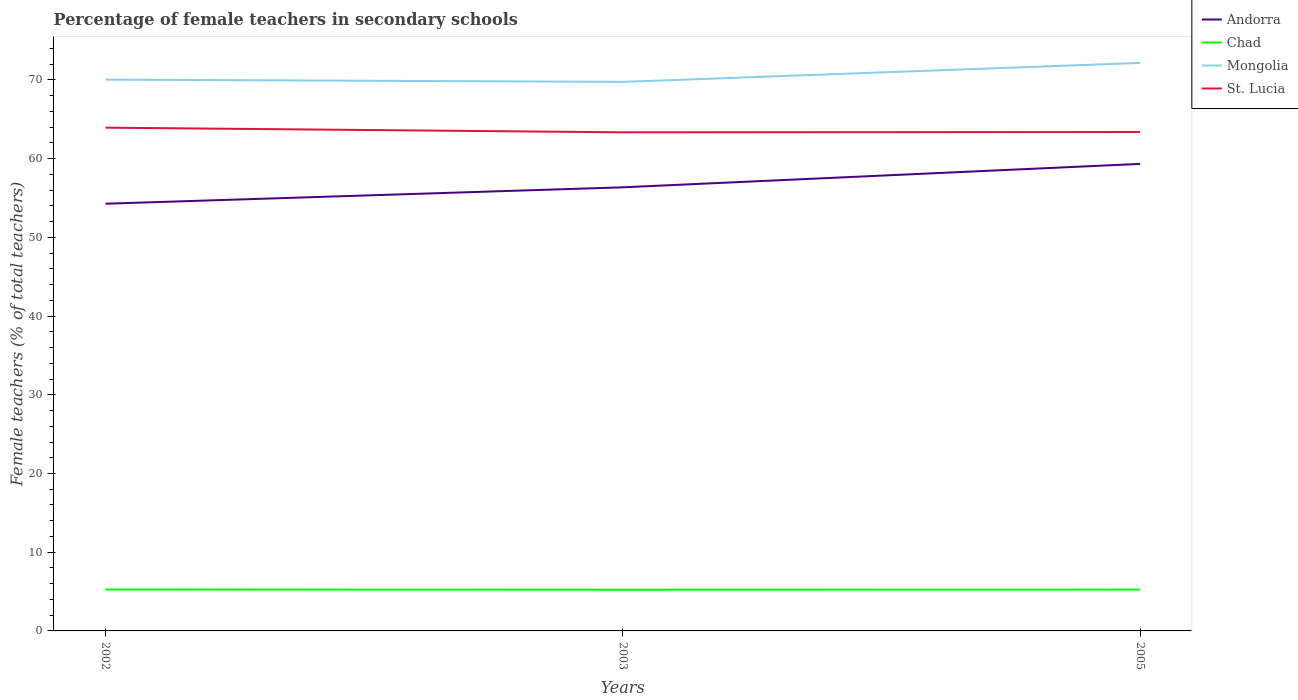How many different coloured lines are there?
Provide a short and direct response. 4. Is the number of lines equal to the number of legend labels?
Offer a very short reply. Yes. Across all years, what is the maximum percentage of female teachers in Chad?
Make the answer very short. 5.23. In which year was the percentage of female teachers in Andorra maximum?
Make the answer very short. 2002. What is the total percentage of female teachers in St. Lucia in the graph?
Provide a succinct answer. 0.56. What is the difference between the highest and the second highest percentage of female teachers in Andorra?
Your answer should be very brief. 5.06. How many lines are there?
Keep it short and to the point. 4. How many years are there in the graph?
Keep it short and to the point. 3. What is the difference between two consecutive major ticks on the Y-axis?
Provide a succinct answer. 10. Does the graph contain any zero values?
Give a very brief answer. No. Does the graph contain grids?
Your answer should be very brief. No. Where does the legend appear in the graph?
Your answer should be compact. Top right. What is the title of the graph?
Make the answer very short. Percentage of female teachers in secondary schools. Does "Andorra" appear as one of the legend labels in the graph?
Offer a very short reply. Yes. What is the label or title of the X-axis?
Your answer should be compact. Years. What is the label or title of the Y-axis?
Offer a terse response. Female teachers (% of total teachers). What is the Female teachers (% of total teachers) of Andorra in 2002?
Your answer should be compact. 54.28. What is the Female teachers (% of total teachers) in Chad in 2002?
Your answer should be compact. 5.26. What is the Female teachers (% of total teachers) of Mongolia in 2002?
Offer a very short reply. 70.05. What is the Female teachers (% of total teachers) of St. Lucia in 2002?
Offer a terse response. 63.94. What is the Female teachers (% of total teachers) of Andorra in 2003?
Keep it short and to the point. 56.36. What is the Female teachers (% of total teachers) of Chad in 2003?
Your answer should be compact. 5.23. What is the Female teachers (% of total teachers) of Mongolia in 2003?
Your answer should be compact. 69.76. What is the Female teachers (% of total teachers) in St. Lucia in 2003?
Provide a short and direct response. 63.35. What is the Female teachers (% of total teachers) in Andorra in 2005?
Provide a short and direct response. 59.34. What is the Female teachers (% of total teachers) in Chad in 2005?
Keep it short and to the point. 5.25. What is the Female teachers (% of total teachers) of Mongolia in 2005?
Offer a very short reply. 72.17. What is the Female teachers (% of total teachers) in St. Lucia in 2005?
Keep it short and to the point. 63.39. Across all years, what is the maximum Female teachers (% of total teachers) of Andorra?
Your answer should be compact. 59.34. Across all years, what is the maximum Female teachers (% of total teachers) in Chad?
Your answer should be very brief. 5.26. Across all years, what is the maximum Female teachers (% of total teachers) of Mongolia?
Your response must be concise. 72.17. Across all years, what is the maximum Female teachers (% of total teachers) of St. Lucia?
Make the answer very short. 63.94. Across all years, what is the minimum Female teachers (% of total teachers) of Andorra?
Give a very brief answer. 54.28. Across all years, what is the minimum Female teachers (% of total teachers) in Chad?
Offer a terse response. 5.23. Across all years, what is the minimum Female teachers (% of total teachers) of Mongolia?
Your answer should be very brief. 69.76. Across all years, what is the minimum Female teachers (% of total teachers) in St. Lucia?
Give a very brief answer. 63.35. What is the total Female teachers (% of total teachers) in Andorra in the graph?
Your answer should be compact. 169.98. What is the total Female teachers (% of total teachers) of Chad in the graph?
Provide a short and direct response. 15.75. What is the total Female teachers (% of total teachers) of Mongolia in the graph?
Make the answer very short. 211.97. What is the total Female teachers (% of total teachers) of St. Lucia in the graph?
Give a very brief answer. 190.68. What is the difference between the Female teachers (% of total teachers) of Andorra in 2002 and that in 2003?
Your response must be concise. -2.08. What is the difference between the Female teachers (% of total teachers) of Chad in 2002 and that in 2003?
Keep it short and to the point. 0.03. What is the difference between the Female teachers (% of total teachers) of Mongolia in 2002 and that in 2003?
Offer a very short reply. 0.29. What is the difference between the Female teachers (% of total teachers) of St. Lucia in 2002 and that in 2003?
Give a very brief answer. 0.59. What is the difference between the Female teachers (% of total teachers) in Andorra in 2002 and that in 2005?
Give a very brief answer. -5.06. What is the difference between the Female teachers (% of total teachers) of Chad in 2002 and that in 2005?
Keep it short and to the point. 0.01. What is the difference between the Female teachers (% of total teachers) in Mongolia in 2002 and that in 2005?
Provide a succinct answer. -2.12. What is the difference between the Female teachers (% of total teachers) in St. Lucia in 2002 and that in 2005?
Your answer should be compact. 0.56. What is the difference between the Female teachers (% of total teachers) in Andorra in 2003 and that in 2005?
Keep it short and to the point. -2.97. What is the difference between the Female teachers (% of total teachers) in Chad in 2003 and that in 2005?
Keep it short and to the point. -0.02. What is the difference between the Female teachers (% of total teachers) of Mongolia in 2003 and that in 2005?
Offer a terse response. -2.41. What is the difference between the Female teachers (% of total teachers) of St. Lucia in 2003 and that in 2005?
Offer a terse response. -0.04. What is the difference between the Female teachers (% of total teachers) of Andorra in 2002 and the Female teachers (% of total teachers) of Chad in 2003?
Offer a terse response. 49.05. What is the difference between the Female teachers (% of total teachers) in Andorra in 2002 and the Female teachers (% of total teachers) in Mongolia in 2003?
Your answer should be compact. -15.48. What is the difference between the Female teachers (% of total teachers) of Andorra in 2002 and the Female teachers (% of total teachers) of St. Lucia in 2003?
Make the answer very short. -9.07. What is the difference between the Female teachers (% of total teachers) of Chad in 2002 and the Female teachers (% of total teachers) of Mongolia in 2003?
Offer a terse response. -64.49. What is the difference between the Female teachers (% of total teachers) of Chad in 2002 and the Female teachers (% of total teachers) of St. Lucia in 2003?
Provide a short and direct response. -58.09. What is the difference between the Female teachers (% of total teachers) of Mongolia in 2002 and the Female teachers (% of total teachers) of St. Lucia in 2003?
Your answer should be compact. 6.7. What is the difference between the Female teachers (% of total teachers) in Andorra in 2002 and the Female teachers (% of total teachers) in Chad in 2005?
Give a very brief answer. 49.03. What is the difference between the Female teachers (% of total teachers) of Andorra in 2002 and the Female teachers (% of total teachers) of Mongolia in 2005?
Provide a succinct answer. -17.89. What is the difference between the Female teachers (% of total teachers) in Andorra in 2002 and the Female teachers (% of total teachers) in St. Lucia in 2005?
Provide a succinct answer. -9.11. What is the difference between the Female teachers (% of total teachers) in Chad in 2002 and the Female teachers (% of total teachers) in Mongolia in 2005?
Your answer should be very brief. -66.91. What is the difference between the Female teachers (% of total teachers) of Chad in 2002 and the Female teachers (% of total teachers) of St. Lucia in 2005?
Give a very brief answer. -58.12. What is the difference between the Female teachers (% of total teachers) in Mongolia in 2002 and the Female teachers (% of total teachers) in St. Lucia in 2005?
Provide a succinct answer. 6.66. What is the difference between the Female teachers (% of total teachers) in Andorra in 2003 and the Female teachers (% of total teachers) in Chad in 2005?
Ensure brevity in your answer.  51.11. What is the difference between the Female teachers (% of total teachers) in Andorra in 2003 and the Female teachers (% of total teachers) in Mongolia in 2005?
Provide a succinct answer. -15.8. What is the difference between the Female teachers (% of total teachers) in Andorra in 2003 and the Female teachers (% of total teachers) in St. Lucia in 2005?
Offer a terse response. -7.02. What is the difference between the Female teachers (% of total teachers) of Chad in 2003 and the Female teachers (% of total teachers) of Mongolia in 2005?
Offer a very short reply. -66.94. What is the difference between the Female teachers (% of total teachers) of Chad in 2003 and the Female teachers (% of total teachers) of St. Lucia in 2005?
Keep it short and to the point. -58.16. What is the difference between the Female teachers (% of total teachers) in Mongolia in 2003 and the Female teachers (% of total teachers) in St. Lucia in 2005?
Offer a very short reply. 6.37. What is the average Female teachers (% of total teachers) of Andorra per year?
Offer a terse response. 56.66. What is the average Female teachers (% of total teachers) of Chad per year?
Offer a very short reply. 5.25. What is the average Female teachers (% of total teachers) of Mongolia per year?
Ensure brevity in your answer.  70.66. What is the average Female teachers (% of total teachers) in St. Lucia per year?
Offer a terse response. 63.56. In the year 2002, what is the difference between the Female teachers (% of total teachers) of Andorra and Female teachers (% of total teachers) of Chad?
Give a very brief answer. 49.02. In the year 2002, what is the difference between the Female teachers (% of total teachers) in Andorra and Female teachers (% of total teachers) in Mongolia?
Your response must be concise. -15.77. In the year 2002, what is the difference between the Female teachers (% of total teachers) in Andorra and Female teachers (% of total teachers) in St. Lucia?
Offer a very short reply. -9.66. In the year 2002, what is the difference between the Female teachers (% of total teachers) in Chad and Female teachers (% of total teachers) in Mongolia?
Provide a succinct answer. -64.78. In the year 2002, what is the difference between the Female teachers (% of total teachers) of Chad and Female teachers (% of total teachers) of St. Lucia?
Provide a short and direct response. -58.68. In the year 2002, what is the difference between the Female teachers (% of total teachers) in Mongolia and Female teachers (% of total teachers) in St. Lucia?
Keep it short and to the point. 6.1. In the year 2003, what is the difference between the Female teachers (% of total teachers) of Andorra and Female teachers (% of total teachers) of Chad?
Give a very brief answer. 51.13. In the year 2003, what is the difference between the Female teachers (% of total teachers) in Andorra and Female teachers (% of total teachers) in Mongolia?
Your answer should be compact. -13.39. In the year 2003, what is the difference between the Female teachers (% of total teachers) in Andorra and Female teachers (% of total teachers) in St. Lucia?
Keep it short and to the point. -6.99. In the year 2003, what is the difference between the Female teachers (% of total teachers) of Chad and Female teachers (% of total teachers) of Mongolia?
Ensure brevity in your answer.  -64.53. In the year 2003, what is the difference between the Female teachers (% of total teachers) of Chad and Female teachers (% of total teachers) of St. Lucia?
Make the answer very short. -58.12. In the year 2003, what is the difference between the Female teachers (% of total teachers) in Mongolia and Female teachers (% of total teachers) in St. Lucia?
Provide a short and direct response. 6.41. In the year 2005, what is the difference between the Female teachers (% of total teachers) in Andorra and Female teachers (% of total teachers) in Chad?
Offer a very short reply. 54.08. In the year 2005, what is the difference between the Female teachers (% of total teachers) of Andorra and Female teachers (% of total teachers) of Mongolia?
Keep it short and to the point. -12.83. In the year 2005, what is the difference between the Female teachers (% of total teachers) of Andorra and Female teachers (% of total teachers) of St. Lucia?
Provide a short and direct response. -4.05. In the year 2005, what is the difference between the Female teachers (% of total teachers) in Chad and Female teachers (% of total teachers) in Mongolia?
Offer a very short reply. -66.92. In the year 2005, what is the difference between the Female teachers (% of total teachers) of Chad and Female teachers (% of total teachers) of St. Lucia?
Your answer should be compact. -58.14. In the year 2005, what is the difference between the Female teachers (% of total teachers) in Mongolia and Female teachers (% of total teachers) in St. Lucia?
Make the answer very short. 8.78. What is the ratio of the Female teachers (% of total teachers) in Andorra in 2002 to that in 2003?
Your response must be concise. 0.96. What is the ratio of the Female teachers (% of total teachers) of Chad in 2002 to that in 2003?
Make the answer very short. 1.01. What is the ratio of the Female teachers (% of total teachers) in St. Lucia in 2002 to that in 2003?
Offer a very short reply. 1.01. What is the ratio of the Female teachers (% of total teachers) in Andorra in 2002 to that in 2005?
Give a very brief answer. 0.91. What is the ratio of the Female teachers (% of total teachers) in Chad in 2002 to that in 2005?
Offer a terse response. 1. What is the ratio of the Female teachers (% of total teachers) of Mongolia in 2002 to that in 2005?
Ensure brevity in your answer.  0.97. What is the ratio of the Female teachers (% of total teachers) of St. Lucia in 2002 to that in 2005?
Provide a succinct answer. 1.01. What is the ratio of the Female teachers (% of total teachers) of Andorra in 2003 to that in 2005?
Make the answer very short. 0.95. What is the ratio of the Female teachers (% of total teachers) in Chad in 2003 to that in 2005?
Provide a short and direct response. 1. What is the ratio of the Female teachers (% of total teachers) of Mongolia in 2003 to that in 2005?
Your response must be concise. 0.97. What is the ratio of the Female teachers (% of total teachers) in St. Lucia in 2003 to that in 2005?
Your answer should be very brief. 1. What is the difference between the highest and the second highest Female teachers (% of total teachers) in Andorra?
Offer a terse response. 2.97. What is the difference between the highest and the second highest Female teachers (% of total teachers) of Chad?
Provide a short and direct response. 0.01. What is the difference between the highest and the second highest Female teachers (% of total teachers) of Mongolia?
Give a very brief answer. 2.12. What is the difference between the highest and the second highest Female teachers (% of total teachers) of St. Lucia?
Keep it short and to the point. 0.56. What is the difference between the highest and the lowest Female teachers (% of total teachers) in Andorra?
Provide a succinct answer. 5.06. What is the difference between the highest and the lowest Female teachers (% of total teachers) of Chad?
Give a very brief answer. 0.03. What is the difference between the highest and the lowest Female teachers (% of total teachers) of Mongolia?
Offer a very short reply. 2.41. What is the difference between the highest and the lowest Female teachers (% of total teachers) of St. Lucia?
Provide a succinct answer. 0.59. 